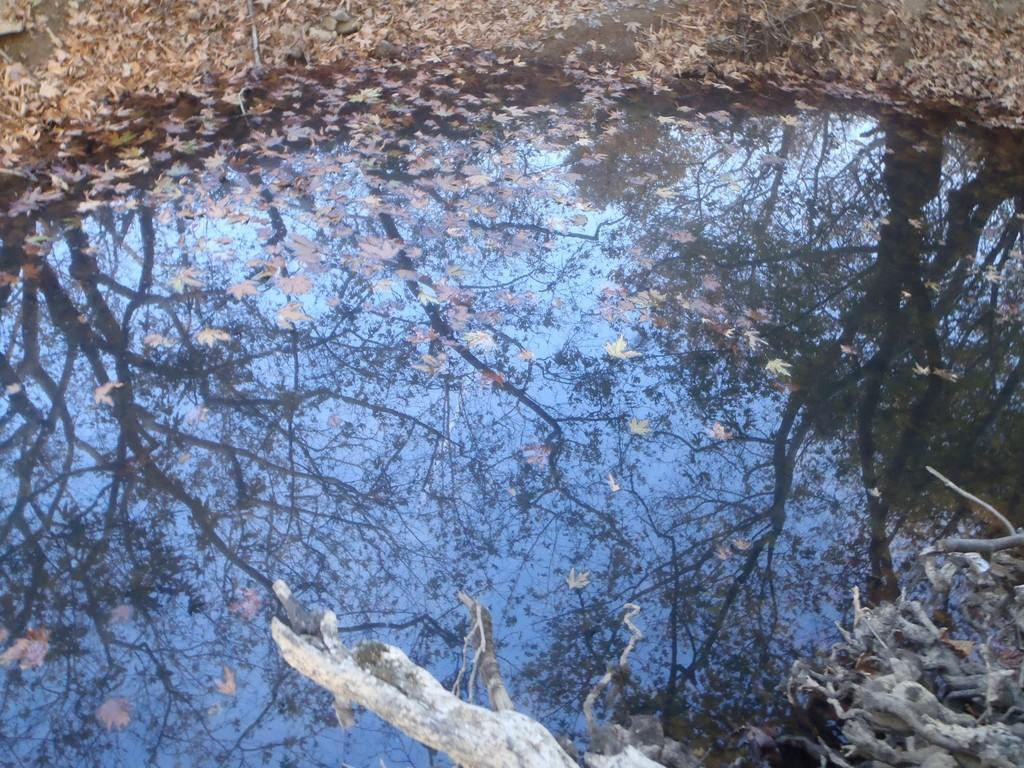What type of natural elements can be seen in the image? There are branches and water visible in the image. What is present on the ground in the image? Dried leaves are present in the image. What can be seen in the water in the image? There is a reflection of trees and the sky in the water. How many points are visible on the branches in the image? The branches in the image do not have points; they are natural branches with no specific geometric shapes. 